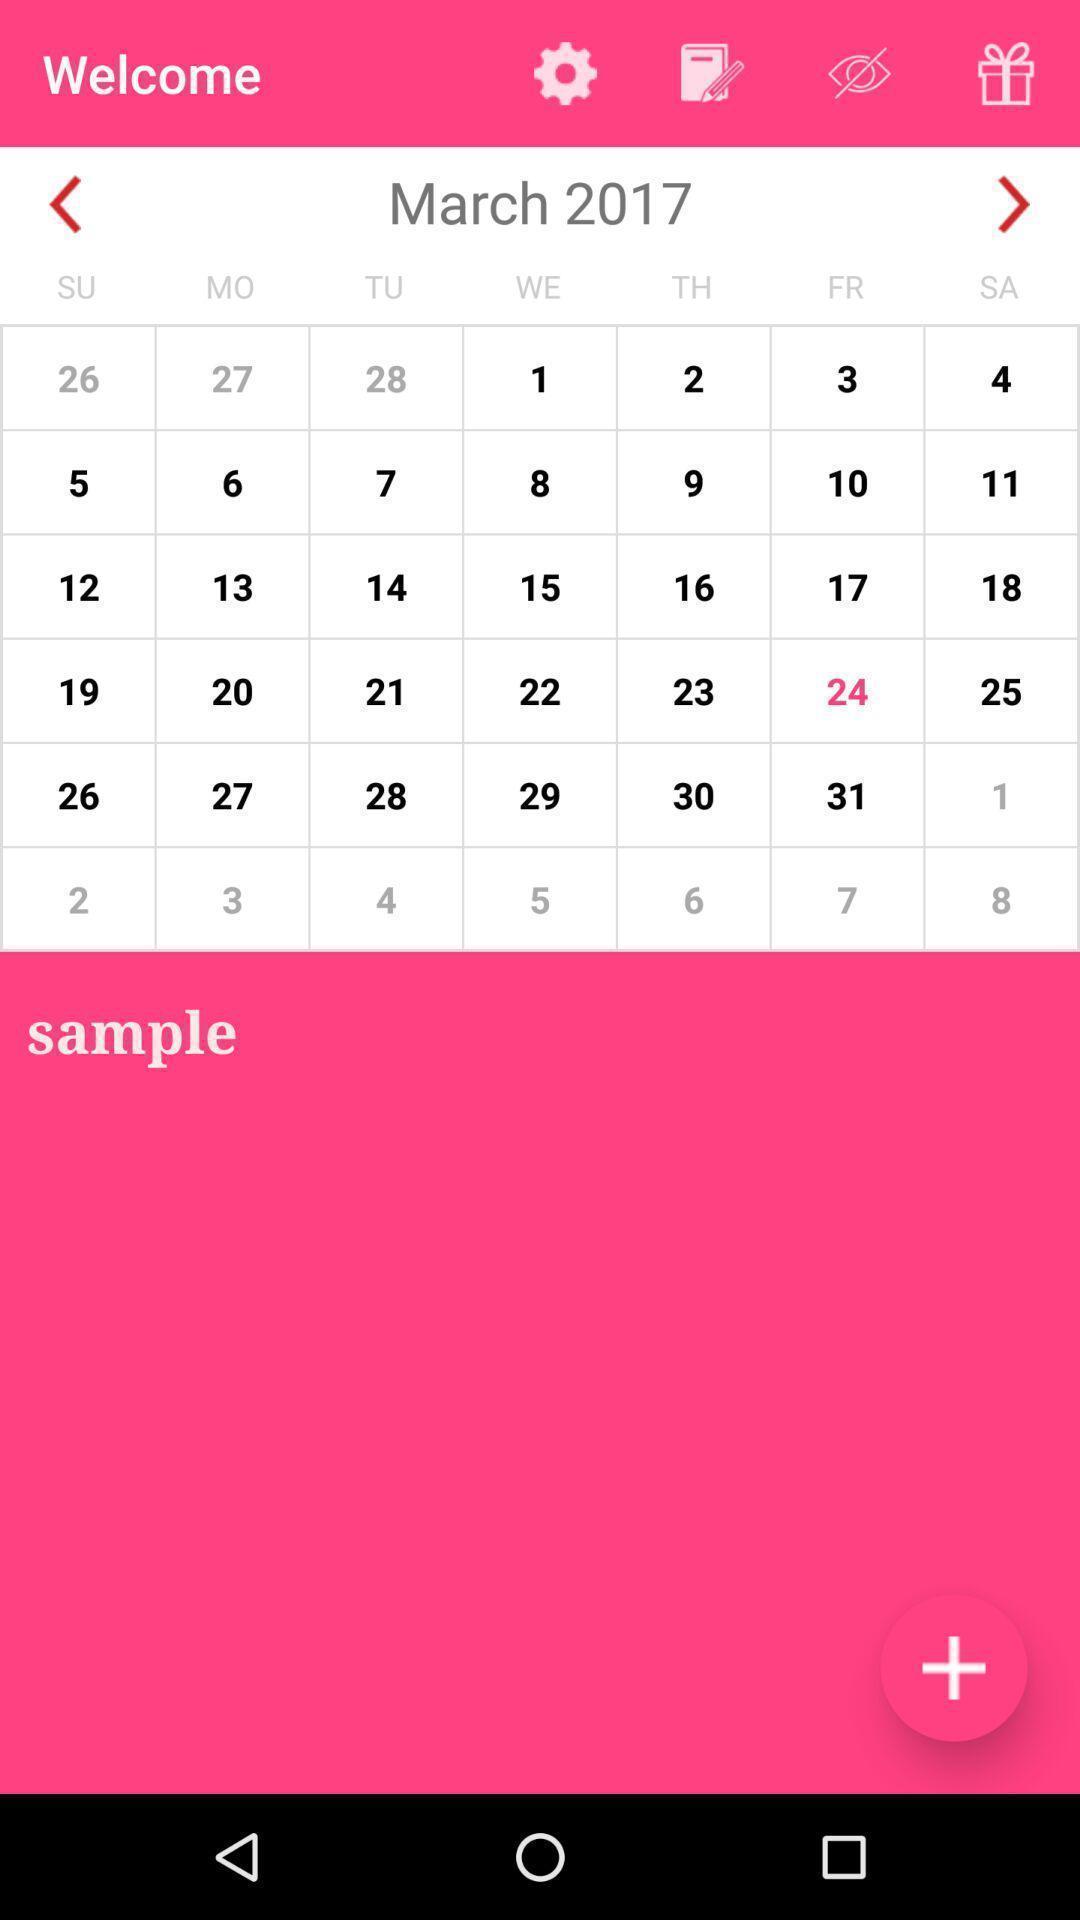Give me a summary of this screen capture. Welcome page with calendar. 